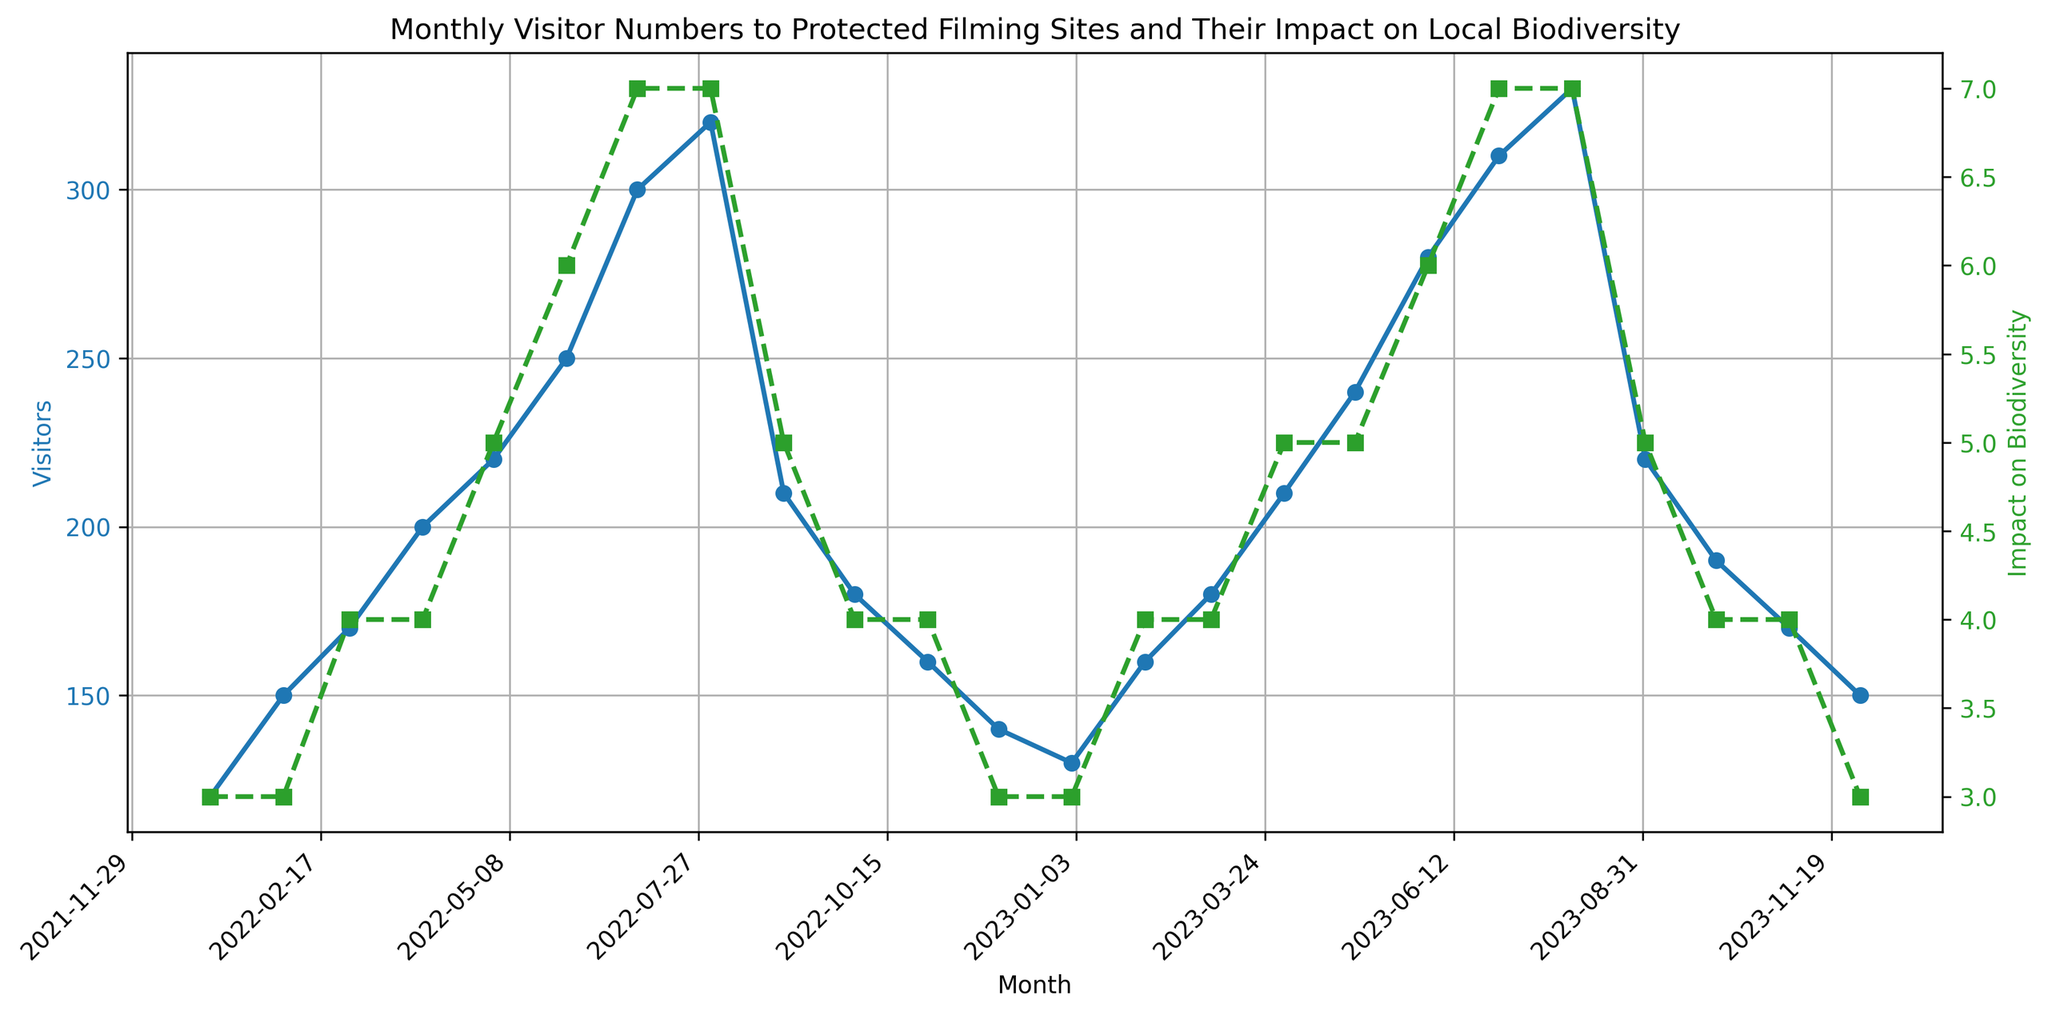When did the visitor count reach its peak? To find the peak visitor count, look for the highest point on the blue line. The highest value of visitors is 330, which occurs in August 2023.
Answer: August 2023 How does the impact on biodiversity in July 2023 compare with January 2022? To compare impacts, identify the values for the specific months on the green line. The impact on biodiversity in July 2023 is 7, while in January 2022, it is 3. Thus, the impact in July 2023 is higher than in January 2022.
Answer: Higher What is the average number of visitors in the months with an impact on biodiversity score of 4? Identify the months with an impact score of 4 (March 2022, April 2022, October 2022, November 2022, February 2023, March 2023, October 2023, and November 2023). The visitor numbers in these months are 170, 200, 180, 160, 160, 180, 190, and 170. The sum of these values is 1310. The average is 1310 / 8.
Answer: 163.75 Was there a month where the visitor numbers declined but the impact on biodiversity remained the same? Look for months where the blue line decreases while the green line remains constant. This occurs from October 2022 to November 2022. Visitor numbers decreased from 180 to 160, but the impact score remained 4.
Answer: Yes By how much did the visitor count increase from December 2022 to August 2023? The visitor count in December 2022 is 140 and in August 2023 is 330. The increase is calculated as 330 - 140.
Answer: 190 In which month did both the number of visitors and the impact on biodiversity score increase the most compared to the previous month? Compare the increases month by month for both metrics. From June 2023 to July 2023, visitor numbers increase by 30 (from 280 to 310) and the impact score increases by 1 (from 6 to 7), which is among the highest increases for both metrics simultaneously.
Answer: July 2023 What trend can be observed in the visitor numbers and impact on biodiversity from June 2023 to August 2023? Observe the blue line (visitor numbers) and the green line (impact score) from June 2023 to August 2023. Both metrics show an increasing trend during these months.
Answer: Increasing How many months had a visitor count above 250? Count the points on the blue line where the visitor count exceeds 250. These months are June 2022, July 2022, August 2022, June 2023, July 2023, and August 2023.
Answer: 6 Which month had the lowest impact on biodiversity and does it coincide with the lowest visitor count? The lowest impact score is 3, which occurs in January 2022, February 2022, December 2022, January 2023, and December 2023. The lowest visitor count is in January 2022 (120). Since the visitor count is lowest in January 2022 with an impact score of 3, it coincides.
Answer: January 2022 What can be inferred about the relationship between visitor numbers and impact on biodiversity from May 2022 to July 2022? Between May 2022 and July 2022, observe that as the visitor numbers increase from 220 to 300, the impact on biodiversity also increases from 5 to 7. This indicates a positive correlation.
Answer: Positive correlation 